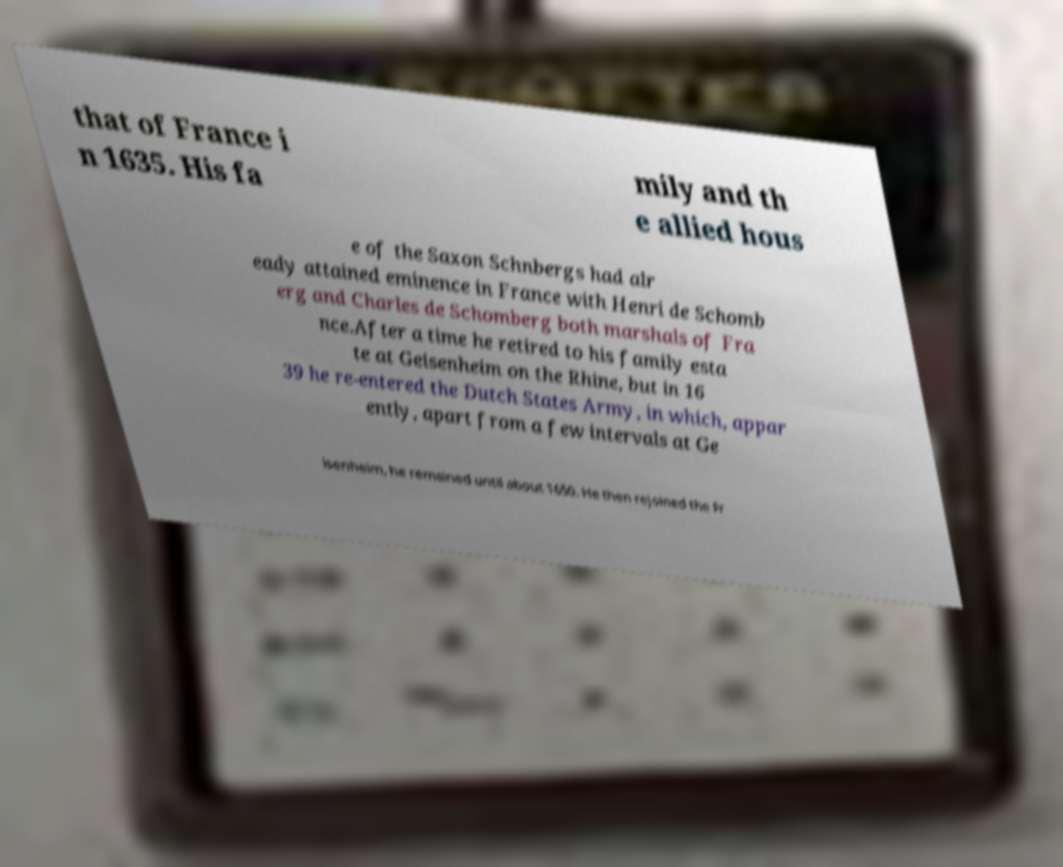For documentation purposes, I need the text within this image transcribed. Could you provide that? that of France i n 1635. His fa mily and th e allied hous e of the Saxon Schnbergs had alr eady attained eminence in France with Henri de Schomb erg and Charles de Schomberg both marshals of Fra nce.After a time he retired to his family esta te at Geisenheim on the Rhine, but in 16 39 he re-entered the Dutch States Army, in which, appar ently, apart from a few intervals at Ge isenheim, he remained until about 1650. He then rejoined the Fr 